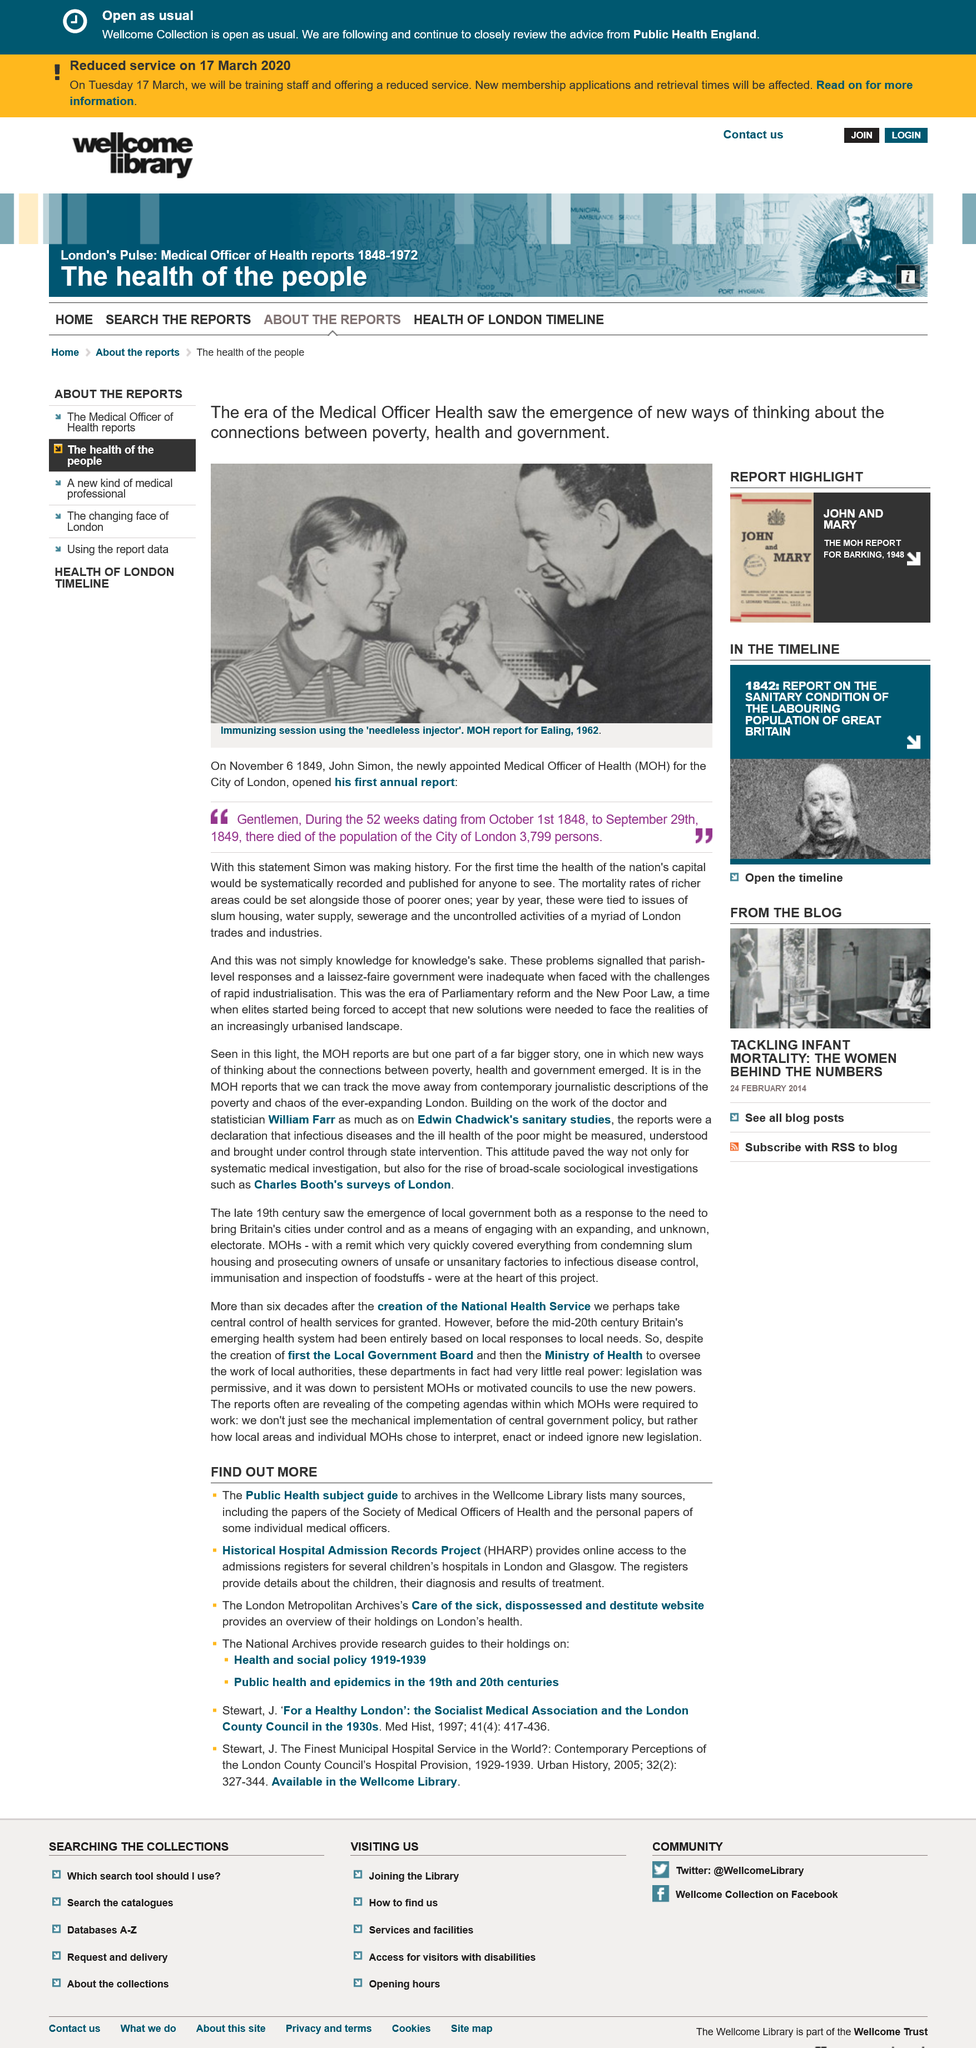List a handful of essential elements in this visual. The acronym HHARP stands for Historical Hospital Admission Records Project, which refers to a database of admission records from hospitals in a specific time period. The Historical Hospital Admission Records Project (HHARP) provides online access to the admissions registers for several children's hospitals in London and Glasgow. The London Metropolitan Archive's website provides an overview of their care of the sick, dispossessed, and destitute, which highlights their holdings on London's health and social history. 